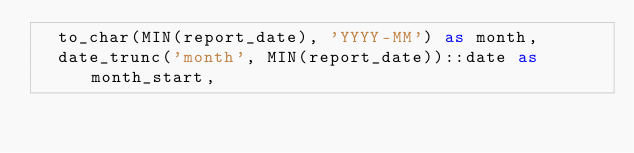<code> <loc_0><loc_0><loc_500><loc_500><_SQL_>  to_char(MIN(report_date), 'YYYY-MM') as month,
  date_trunc('month', MIN(report_date))::date as month_start,
</code> 